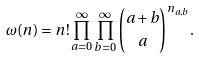<formula> <loc_0><loc_0><loc_500><loc_500>\omega ( n ) = n ! \prod _ { a = 0 } ^ { \infty } \prod _ { b = 0 } ^ { \infty } \binom { a + b } { a } ^ { n _ { a , b } } .</formula> 